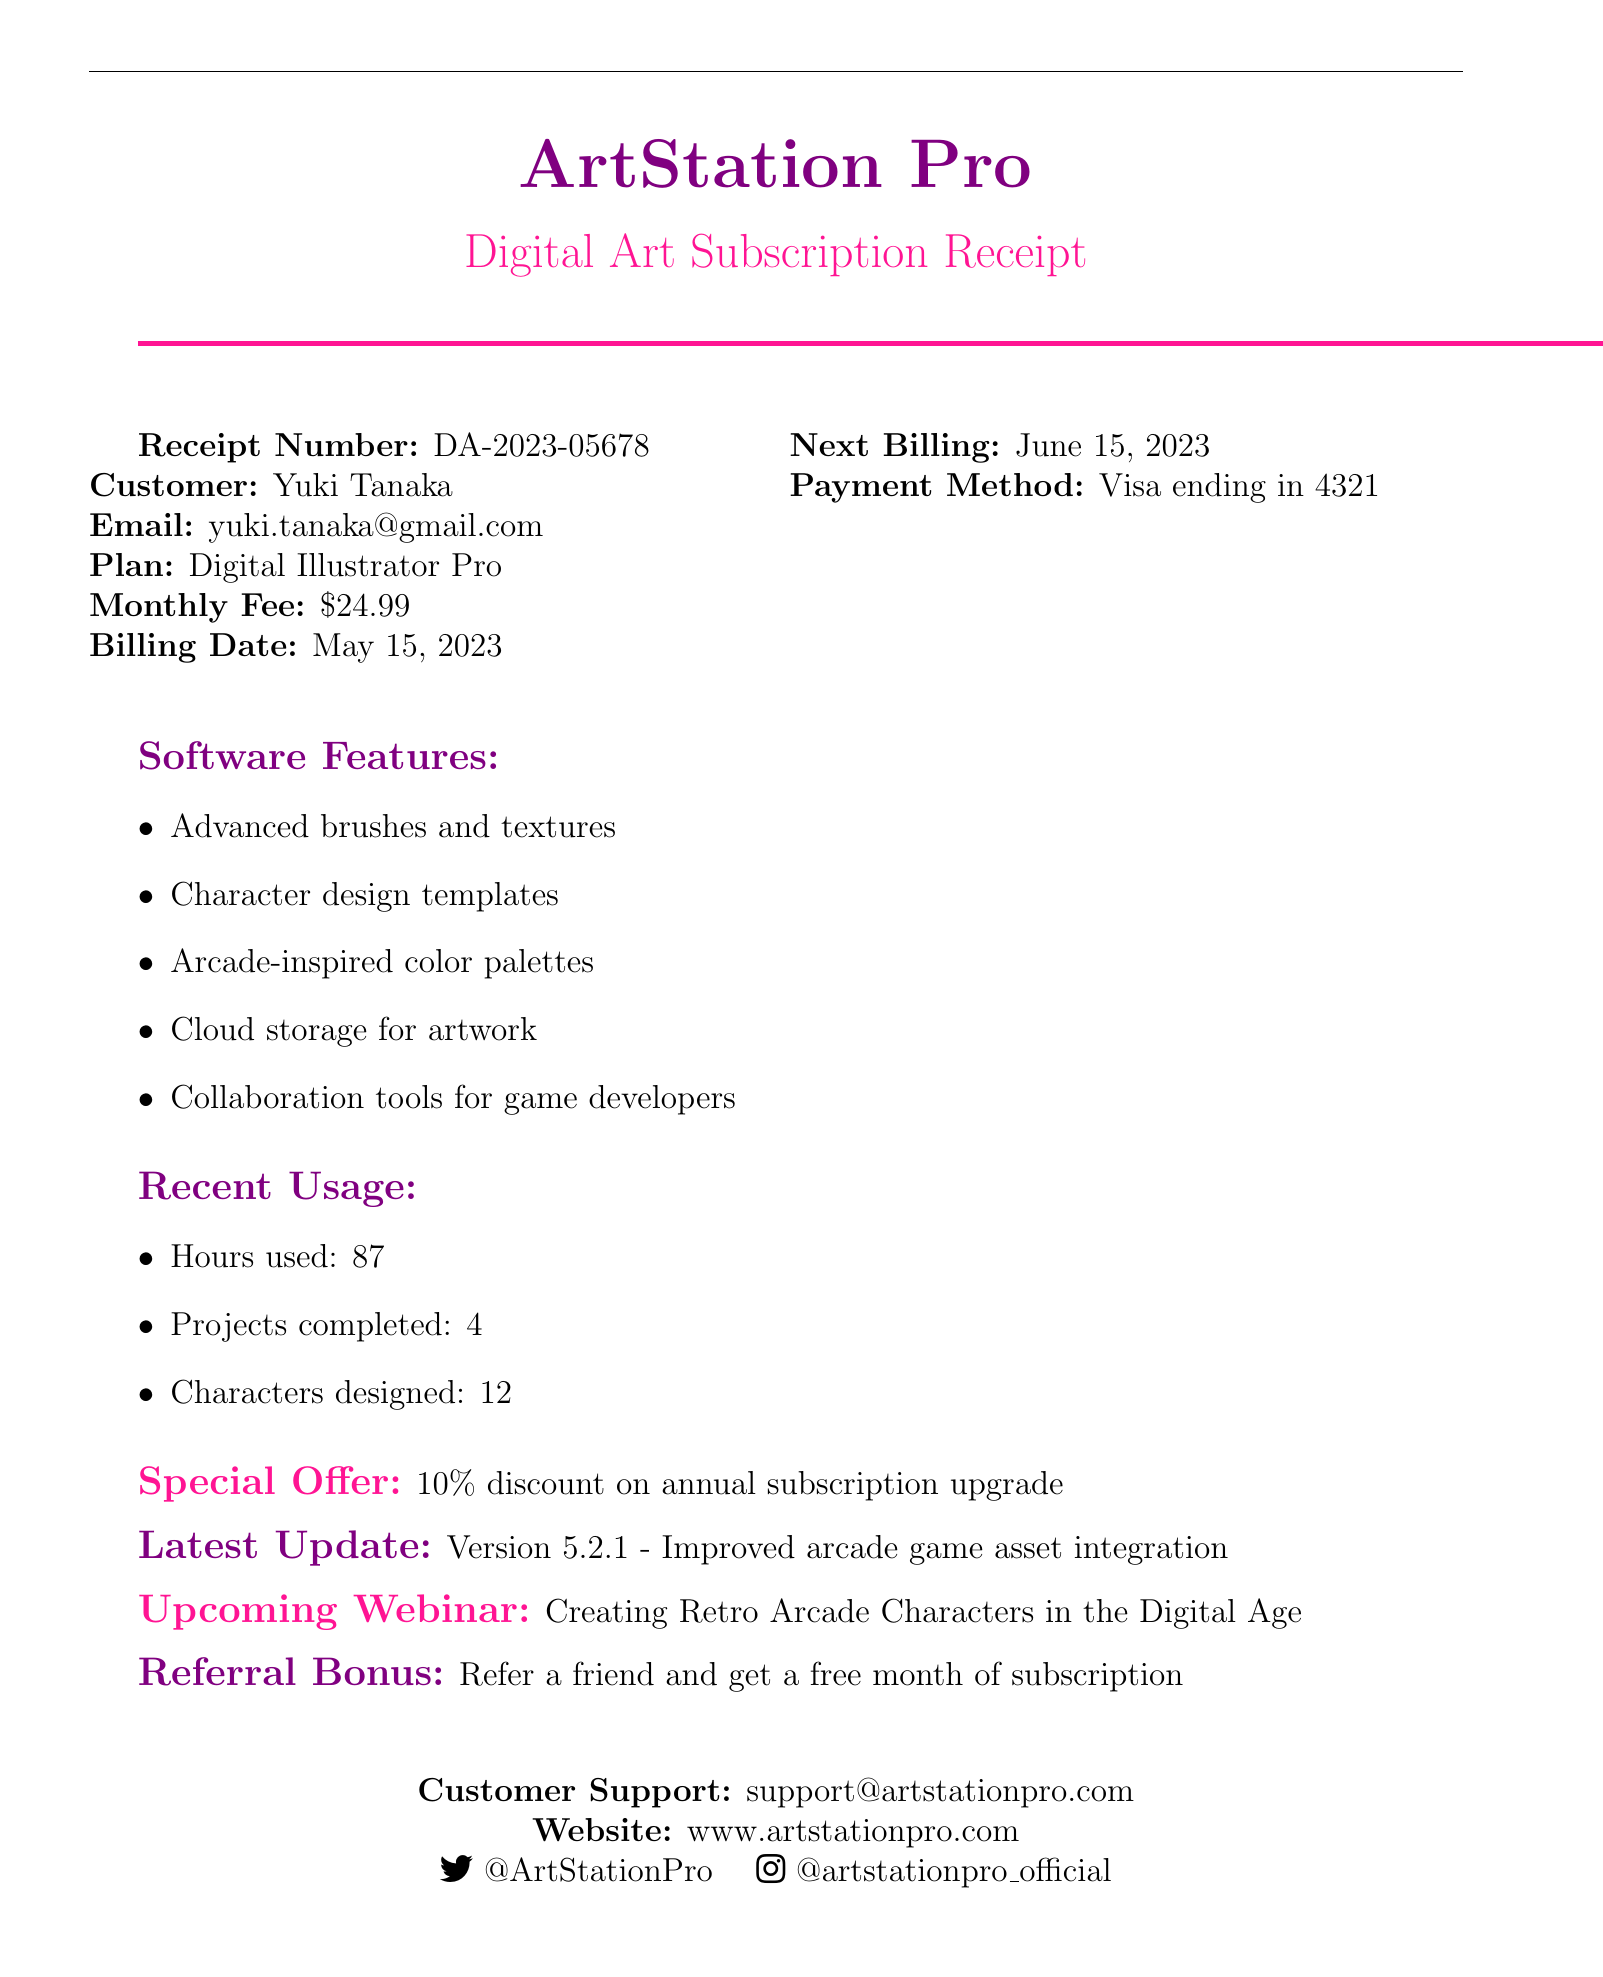What is the receipt number? The receipt number is a unique identifier for the transaction indicated in the document.
Answer: DA-2023-05678 What is the monthly fee for the subscription? The monthly fee represents the amount charged each month for the subscription plan outlined in the document.
Answer: $24.99 When is the next billing date? The next billing date indicates when the customer will be charged again for the subscription, based on the information provided.
Answer: June 15, 2023 Who is the customer? The customer name is listed in the document as part of the transaction details.
Answer: Yuki Tanaka What payment method is used? The payment method shows how the customer will be billed for their subscription service.
Answer: Visa ending in 4321 Which features are included in the software? The software features highlight the various tools and resources available to subscribers, which can enhance their experience.
Answer: Advanced brushes and textures, Character design templates, Arcade-inspired color palettes, Cloud storage for artwork, Collaboration tools for game developers How many characters have been designed recently? The number of characters designed indicates the customer's recent usage of the software, showcasing their activity level.
Answer: 12 What is the special offer mentioned in the document? The special offer provides an incentive to customers, encouraging them to consider an upgrade to their subscription plan.
Answer: 10% discount on annual subscription upgrade What is the latest software update version? The latest software update version indicates the most recent iteration of the software that has been made available to the user.
Answer: Version 5.2.1 What is the upcoming webinar about? The upcoming webinar signifies an educational opportunity provided to customers to enhance their skills related to the software.
Answer: Creating Retro Arcade Characters in the Digital Age 